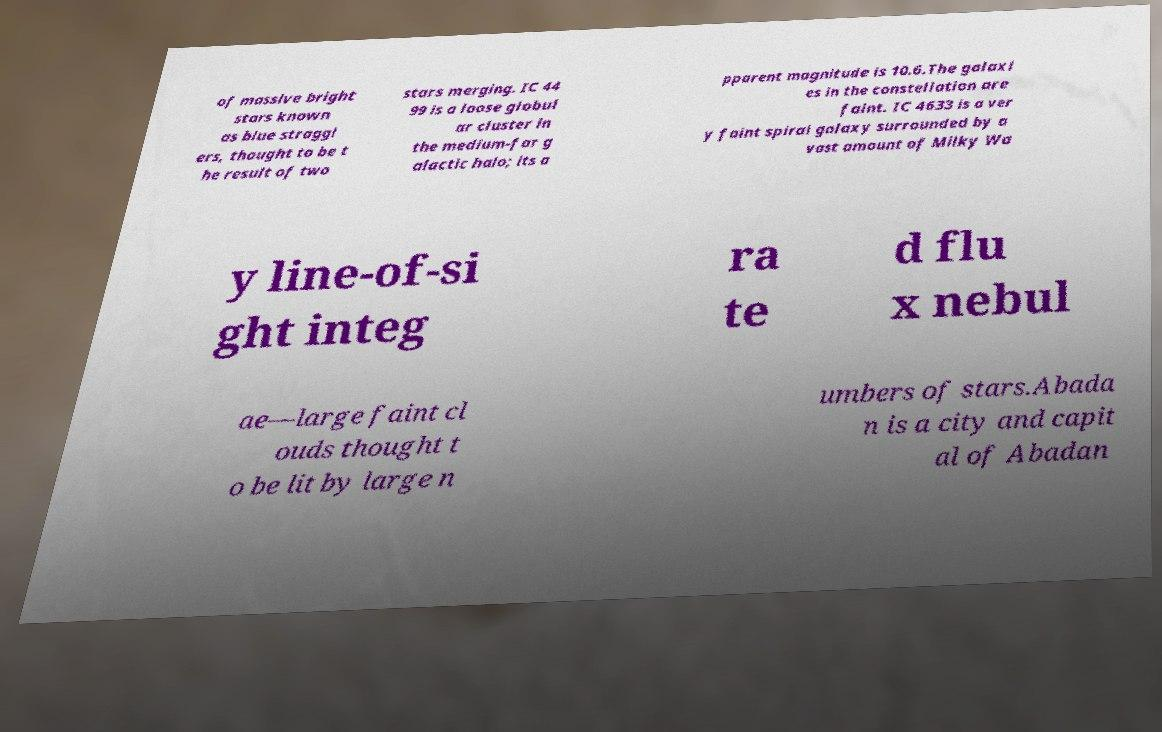There's text embedded in this image that I need extracted. Can you transcribe it verbatim? of massive bright stars known as blue straggl ers, thought to be t he result of two stars merging. IC 44 99 is a loose globul ar cluster in the medium-far g alactic halo; its a pparent magnitude is 10.6.The galaxi es in the constellation are faint. IC 4633 is a ver y faint spiral galaxy surrounded by a vast amount of Milky Wa y line-of-si ght integ ra te d flu x nebul ae—large faint cl ouds thought t o be lit by large n umbers of stars.Abada n is a city and capit al of Abadan 